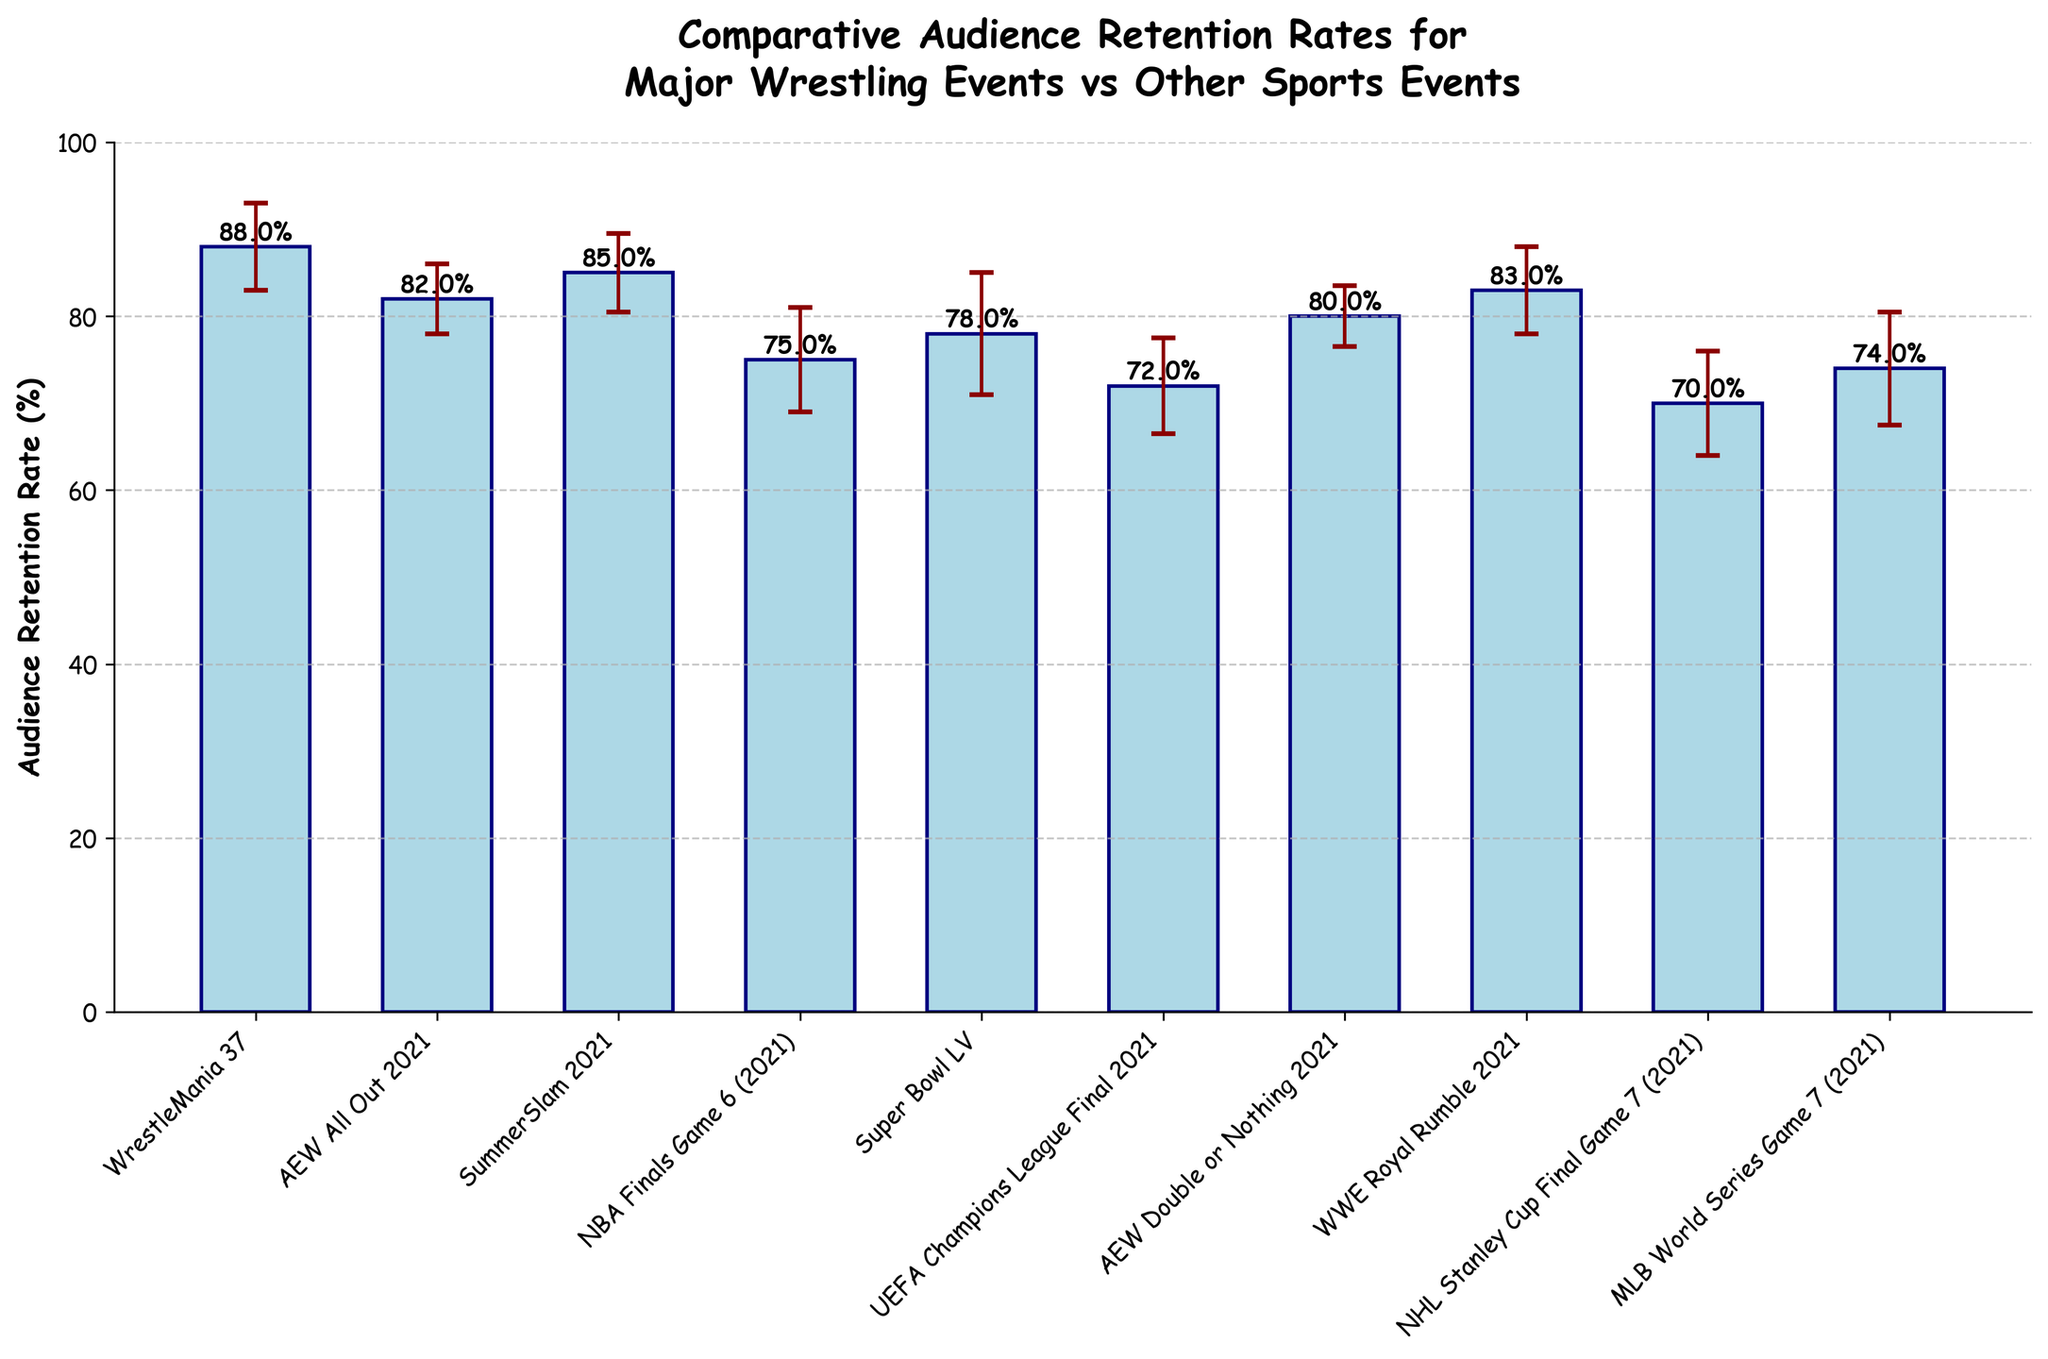What is the title of the chart? The title of the chart is shown at the top and includes two lines for easier readability. The chart is titled “Comparative Audience Retention Rates for Major Wrestling Events vs Other Sports Events.”
Answer: Comparative Audience Retention Rates for Major Wrestling Events vs Other Sports Events What is the retention rate for WrestleMania 37? The retention rate for WrestleMania 37 is given directly by the height of the bar labeled "WrestleMania 37". The height indicates a retention rate of 88%.
Answer: 88% Which event has the lowest audience retention rate? The bar for the NHL Stanley Cup Final Game 7 (2021) is the shortest among all listed events. Its height corresponds to a retention rate of 70%, which is the lowest on the chart.
Answer: NHL Stanley Cup Final Game 7 (2021) How many wrestling events are included in the chart? The x-axis labels have to be checked to count the number of wrestling events. They include WrestleMania 37, AEW All Out 2021, SummerSlam 2021, AEW Double or Nothing 2021, and WWE Royal Rumble 2021, making a total of 5 wrestling events.
Answer: 5 Which event shows the highest standard deviation? The length of the error bars represents the standard deviation. The Super Bowl LV has the longest error bar of 7%, indicating it has the highest standard deviation.
Answer: Super Bowl LV What is the difference in retention rates between the NBA Finals Game 6 (2021) and the MLB World Series Game 7 (2021)? The NBA Finals Game 6 (2021) has a retention rate of 75%, and the MLB World Series Game 7 (2021) has a retention rate of 74%. The difference is calculated as 75% - 74% = 1%.
Answer: 1% What is the average audience retention rate for the wrestling events? The audience retention rates for the wrestling events are: 88% (WrestleMania 37), 82% (AEW All Out 2021), 85% (SummerSlam 2021), 80% (AEW Double or Nothing 2021), and 83% (WWE Royal Rumble 2021). Summing these gives 88 + 82 + 85 + 80 + 83 = 418. Dividing by the number of wrestling events (5) gives an average retention rate of 418/5 = 83.6%.
Answer: 83.6% Which event has a higher retention rate, AEW All Out 2021 or WWE Royal Rumble 2021? The heights of the bars indicate that WWE Royal Rumble 2021 has a retention rate of 83%, which is higher than AEW All Out 2021's retention rate of 82%.
Answer: WWE Royal Rumble 2021 Is the retention rate for SummerSlam 2021 within one standard deviation of the Super Bowl LV’s rate? SummerSlam 2021 has a retention rate of 85% with a standard deviation of 4.5%. The Super Bowl LV has a retention rate of 78% with a standard deviation of 7%. One standard deviation range for the Super Bowl LV is from 71% to 85%. Since 85% falls within this range, the answer is yes.
Answer: Yes What is the range of audience retention rates for the events listed? The maximum retention rate is 88% (WrestleMania 37), and the minimum is 70% (NHL Stanley Cup Final Game 7 (2021)). The range is calculated as 88% - 70% = 18%.
Answer: 18% 